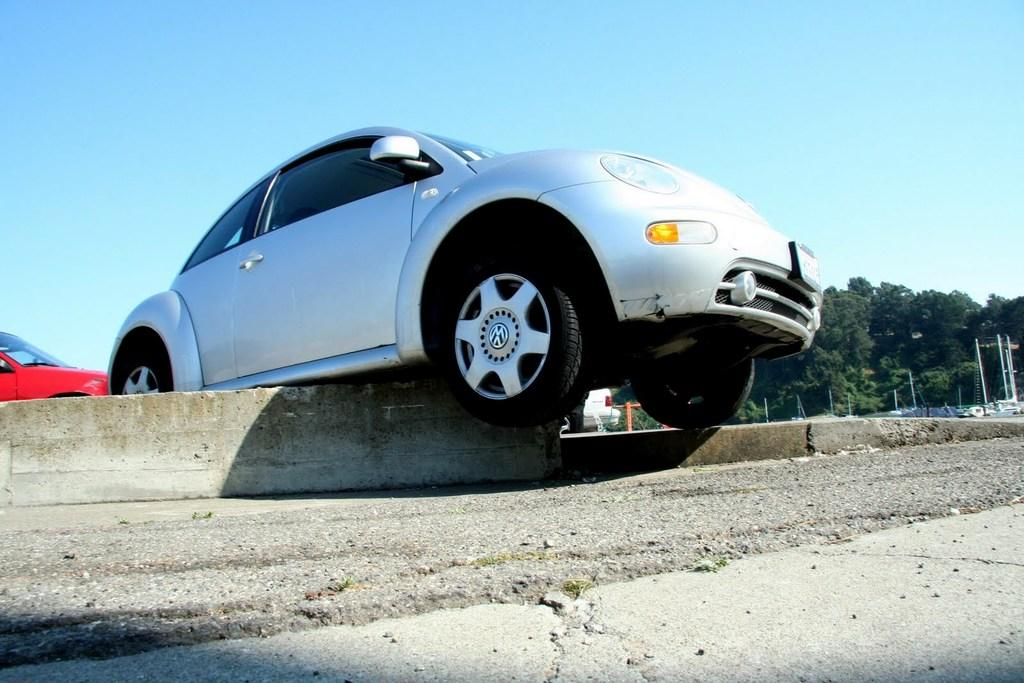What can be seen in the background of the image? There is a sky visible in the background of the image, along with objects and trees. What type of vehicles are present in the image? There are vehicles in the image. What is the primary feature of the image? The primary feature of the image is a road. How many kittens are playing with their mother on the road in the image? There are no kittens or mothers present in the image; it features a road and vehicles. 